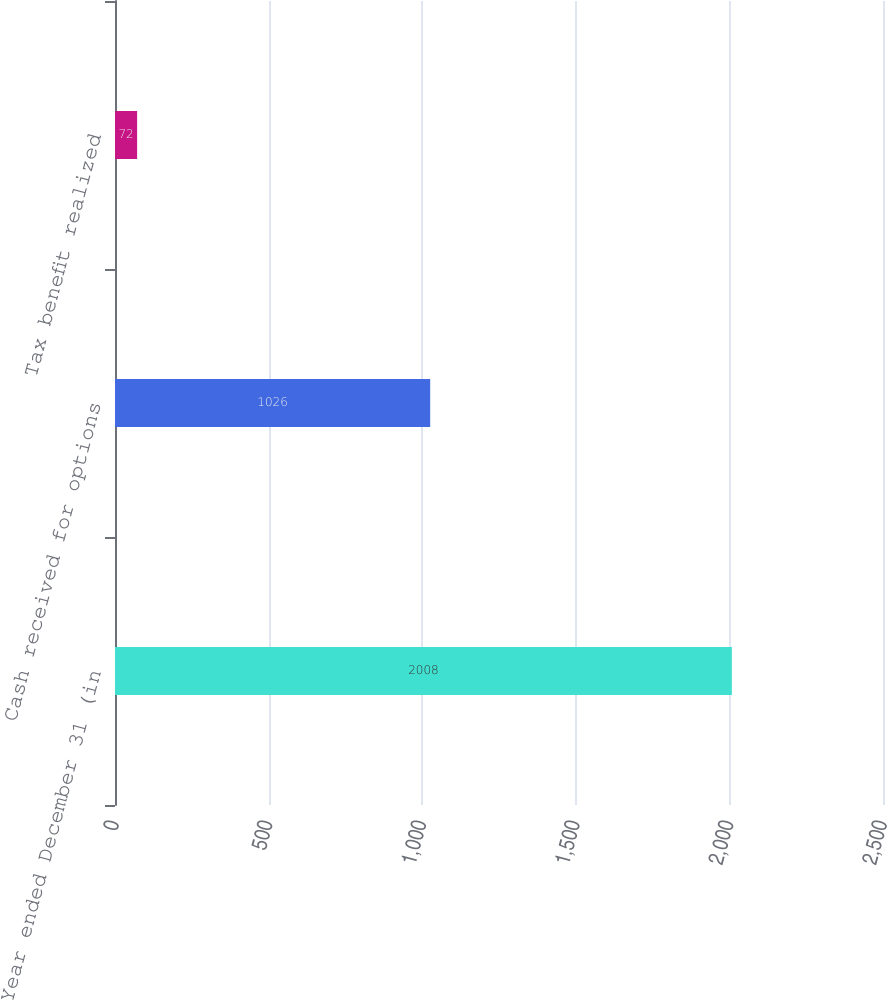Convert chart to OTSL. <chart><loc_0><loc_0><loc_500><loc_500><bar_chart><fcel>Year ended December 31 (in<fcel>Cash received for options<fcel>Tax benefit realized<nl><fcel>2008<fcel>1026<fcel>72<nl></chart> 